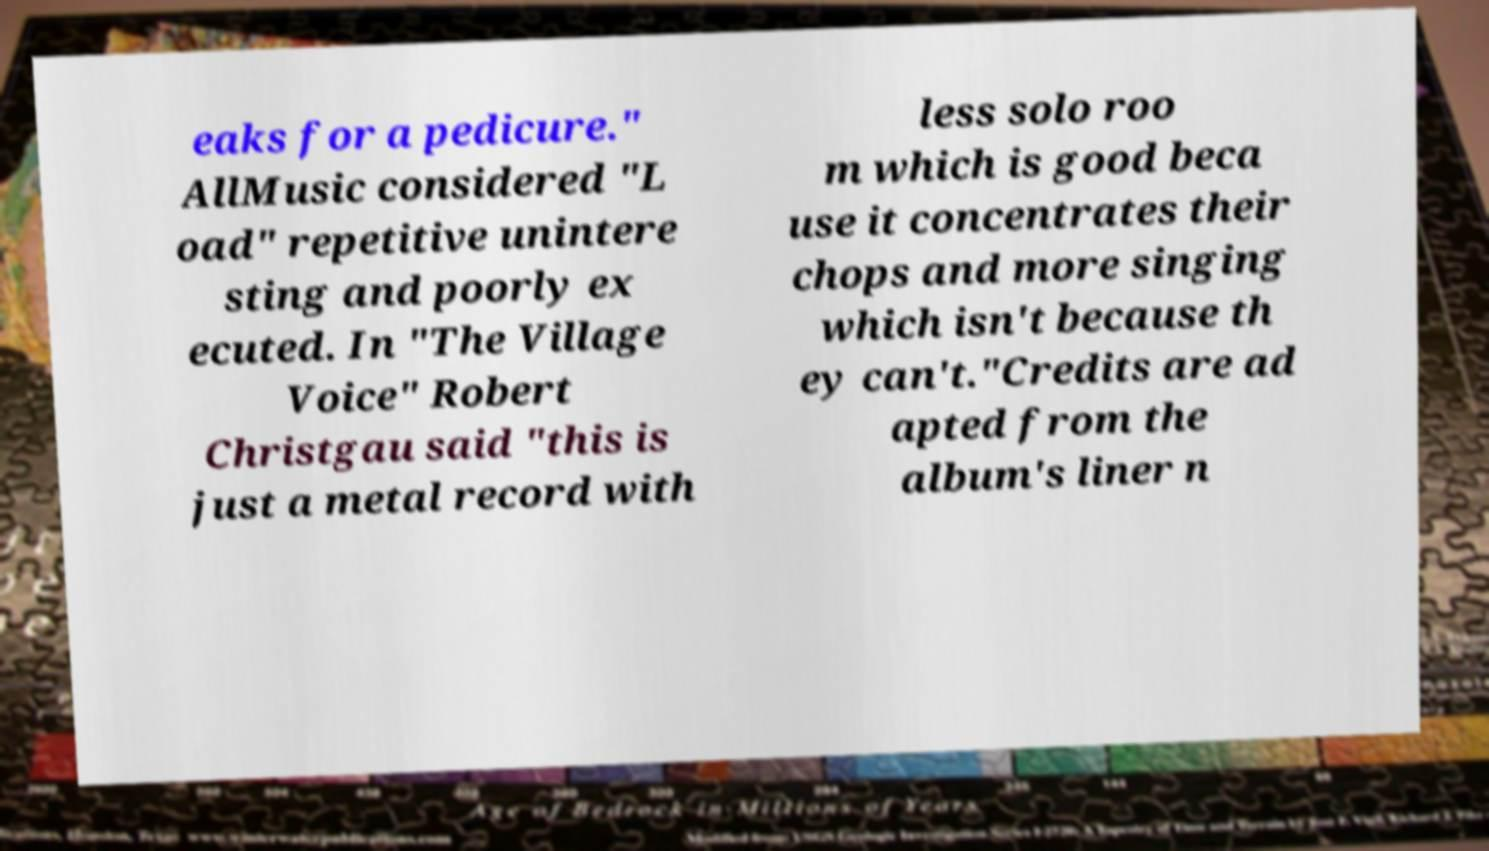Please read and relay the text visible in this image. What does it say? eaks for a pedicure." AllMusic considered "L oad" repetitive unintere sting and poorly ex ecuted. In "The Village Voice" Robert Christgau said "this is just a metal record with less solo roo m which is good beca use it concentrates their chops and more singing which isn't because th ey can't."Credits are ad apted from the album's liner n 